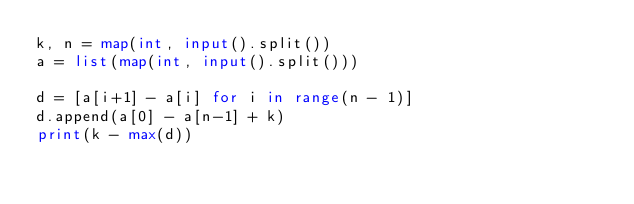Convert code to text. <code><loc_0><loc_0><loc_500><loc_500><_Python_>k, n = map(int, input().split())
a = list(map(int, input().split()))

d = [a[i+1] - a[i] for i in range(n - 1)]
d.append(a[0] - a[n-1] + k)
print(k - max(d))</code> 